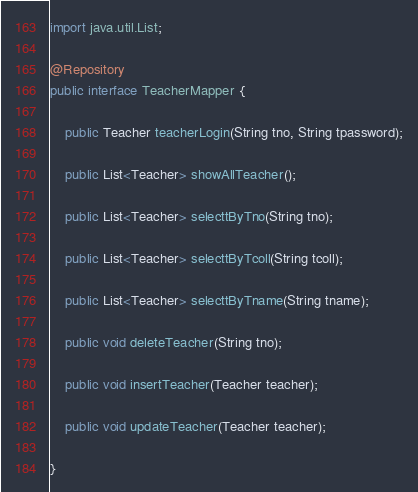<code> <loc_0><loc_0><loc_500><loc_500><_Java_>import java.util.List;

@Repository
public interface TeacherMapper {

    public Teacher teacherLogin(String tno, String tpassword);

    public List<Teacher> showAllTeacher();

    public List<Teacher> selecttByTno(String tno);

    public List<Teacher> selecttByTcoll(String tcoll);

    public List<Teacher> selecttByTname(String tname);

    public void deleteTeacher(String tno);

    public void insertTeacher(Teacher teacher);

    public void updateTeacher(Teacher teacher);

}
</code> 